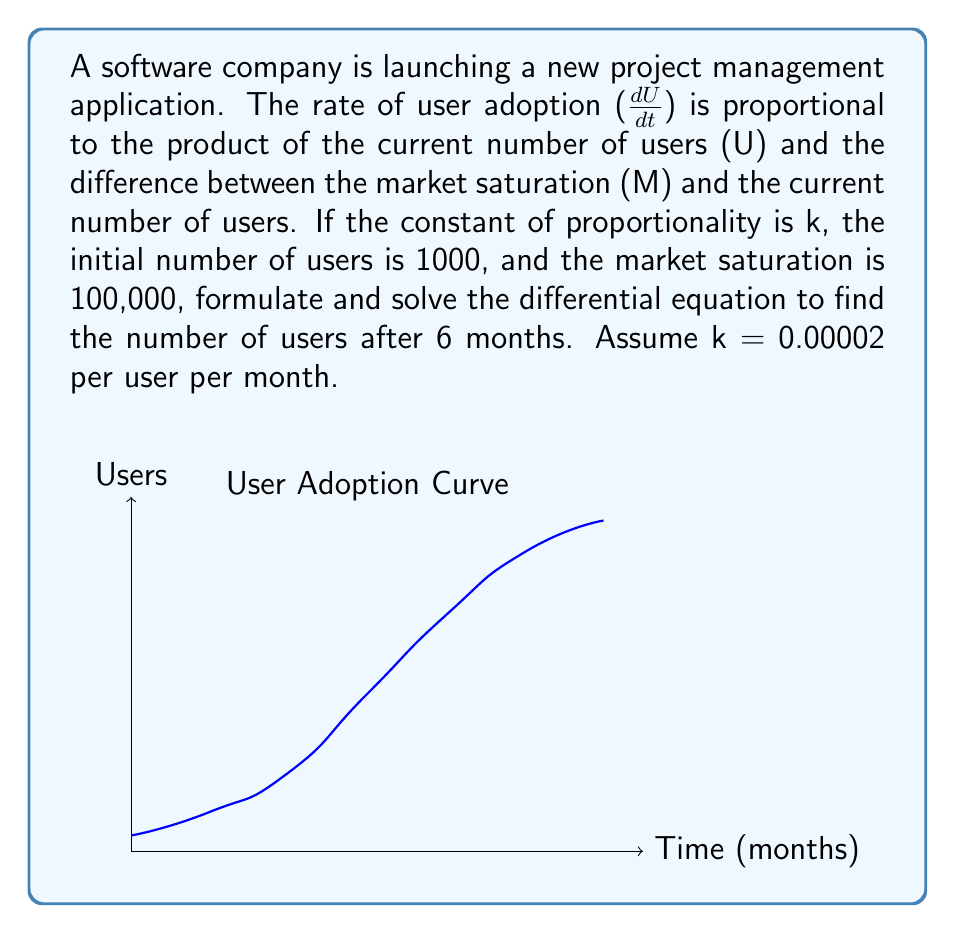What is the answer to this math problem? 1. Formulate the differential equation:
   $$\frac{dU}{dt} = kU(M-U)$$

2. Substitute the given values:
   $$\frac{dU}{dt} = 0.00002U(100000-U)$$

3. This is a separable differential equation. Rearrange it:
   $$\frac{dU}{U(100000-U)} = 0.00002dt$$

4. Integrate both sides:
   $$\int \frac{dU}{U(100000-U)} = \int 0.00002dt$$

5. The left side integrates to:
   $$-\frac{1}{100000}\ln|\frac{100000-U}{U}| = 0.00002t + C$$

6. Use the initial condition U(0) = 1000 to find C:
   $$-\frac{1}{100000}\ln|\frac{100000-1000}{1000}| = C$$
   $$C = -0.04605$$

7. Substitute back and solve for U:
   $$-\frac{1}{100000}\ln|\frac{100000-U}{U}| = 0.00002t - 0.04605$$
   $$\frac{100000-U}{U} = e^{-2t+4605}$$
   $$U = \frac{100000}{1+99e^{-2t}}$$

8. Calculate U when t = 6:
   $$U(6) = \frac{100000}{1+99e^{-12}} \approx 61,589$$
Answer: 61,589 users 